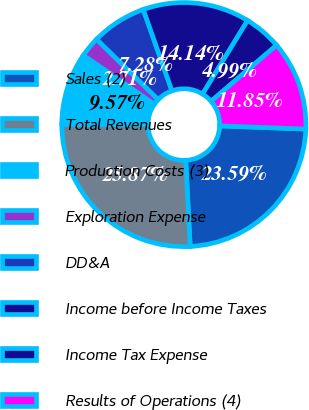Convert chart. <chart><loc_0><loc_0><loc_500><loc_500><pie_chart><fcel>Sales (2)<fcel>Total Revenues<fcel>Production Costs (3)<fcel>Exploration Expense<fcel>DD&A<fcel>Income before Income Taxes<fcel>Income Tax Expense<fcel>Results of Operations (4)<nl><fcel>23.59%<fcel>25.87%<fcel>9.57%<fcel>2.71%<fcel>7.28%<fcel>14.14%<fcel>4.99%<fcel>11.85%<nl></chart> 